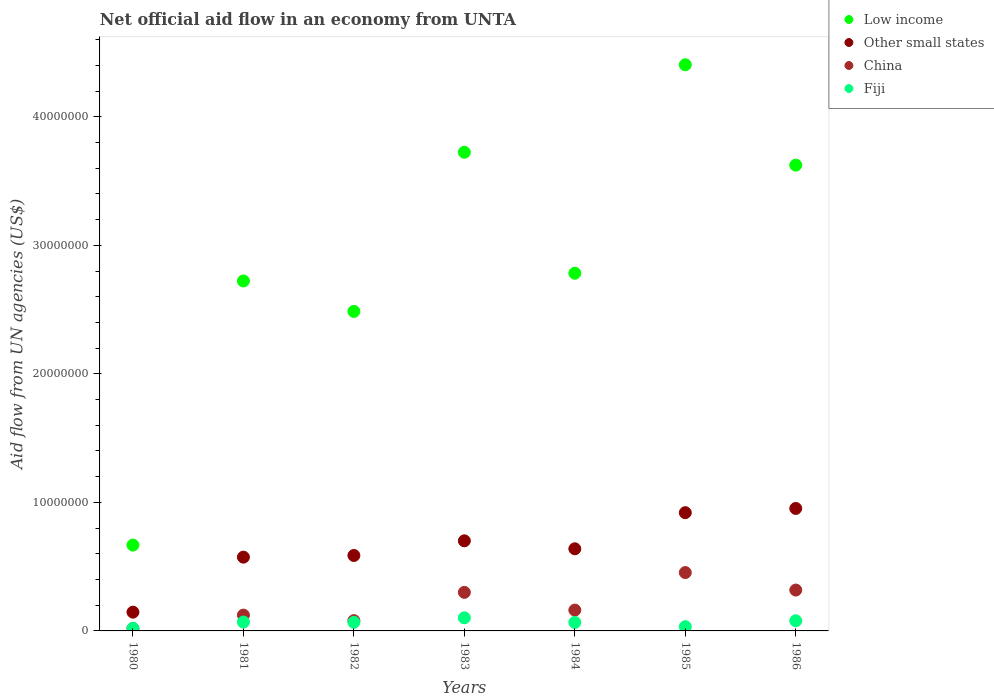How many different coloured dotlines are there?
Provide a short and direct response. 4. What is the net official aid flow in China in 1986?
Offer a very short reply. 3.18e+06. Across all years, what is the maximum net official aid flow in China?
Offer a terse response. 4.54e+06. Across all years, what is the minimum net official aid flow in Other small states?
Provide a succinct answer. 1.46e+06. What is the total net official aid flow in Low income in the graph?
Your response must be concise. 2.04e+08. What is the difference between the net official aid flow in Low income in 1983 and the net official aid flow in Fiji in 1986?
Provide a succinct answer. 3.64e+07. What is the average net official aid flow in China per year?
Make the answer very short. 2.08e+06. In the year 1982, what is the difference between the net official aid flow in Other small states and net official aid flow in Fiji?
Make the answer very short. 5.20e+06. What is the ratio of the net official aid flow in Low income in 1984 to that in 1986?
Your response must be concise. 0.77. Is the net official aid flow in Low income in 1983 less than that in 1985?
Your answer should be compact. Yes. Is the difference between the net official aid flow in Other small states in 1982 and 1984 greater than the difference between the net official aid flow in Fiji in 1982 and 1984?
Give a very brief answer. No. What is the difference between the highest and the second highest net official aid flow in Low income?
Your answer should be compact. 6.81e+06. What is the difference between the highest and the lowest net official aid flow in Low income?
Provide a succinct answer. 3.74e+07. In how many years, is the net official aid flow in Fiji greater than the average net official aid flow in Fiji taken over all years?
Give a very brief answer. 5. Is it the case that in every year, the sum of the net official aid flow in Low income and net official aid flow in Fiji  is greater than the sum of net official aid flow in China and net official aid flow in Other small states?
Your answer should be compact. Yes. Does the net official aid flow in China monotonically increase over the years?
Ensure brevity in your answer.  No. Is the net official aid flow in Other small states strictly less than the net official aid flow in Fiji over the years?
Offer a terse response. No. How many years are there in the graph?
Offer a terse response. 7. What is the difference between two consecutive major ticks on the Y-axis?
Make the answer very short. 1.00e+07. Does the graph contain any zero values?
Your answer should be very brief. No. Does the graph contain grids?
Your answer should be compact. No. How many legend labels are there?
Offer a very short reply. 4. What is the title of the graph?
Keep it short and to the point. Net official aid flow in an economy from UNTA. Does "Aruba" appear as one of the legend labels in the graph?
Offer a terse response. No. What is the label or title of the Y-axis?
Offer a very short reply. Aid flow from UN agencies (US$). What is the Aid flow from UN agencies (US$) in Low income in 1980?
Ensure brevity in your answer.  6.68e+06. What is the Aid flow from UN agencies (US$) of Other small states in 1980?
Offer a terse response. 1.46e+06. What is the Aid flow from UN agencies (US$) in China in 1980?
Provide a succinct answer. 1.90e+05. What is the Aid flow from UN agencies (US$) of Low income in 1981?
Make the answer very short. 2.72e+07. What is the Aid flow from UN agencies (US$) in Other small states in 1981?
Provide a short and direct response. 5.74e+06. What is the Aid flow from UN agencies (US$) in China in 1981?
Provide a short and direct response. 1.23e+06. What is the Aid flow from UN agencies (US$) in Fiji in 1981?
Your answer should be compact. 6.90e+05. What is the Aid flow from UN agencies (US$) of Low income in 1982?
Offer a very short reply. 2.49e+07. What is the Aid flow from UN agencies (US$) of Other small states in 1982?
Your answer should be very brief. 5.87e+06. What is the Aid flow from UN agencies (US$) of Fiji in 1982?
Make the answer very short. 6.70e+05. What is the Aid flow from UN agencies (US$) of Low income in 1983?
Make the answer very short. 3.72e+07. What is the Aid flow from UN agencies (US$) in Other small states in 1983?
Offer a terse response. 7.01e+06. What is the Aid flow from UN agencies (US$) of Fiji in 1983?
Provide a short and direct response. 1.02e+06. What is the Aid flow from UN agencies (US$) in Low income in 1984?
Your answer should be very brief. 2.78e+07. What is the Aid flow from UN agencies (US$) of Other small states in 1984?
Keep it short and to the point. 6.39e+06. What is the Aid flow from UN agencies (US$) of China in 1984?
Your answer should be very brief. 1.62e+06. What is the Aid flow from UN agencies (US$) in Fiji in 1984?
Keep it short and to the point. 6.60e+05. What is the Aid flow from UN agencies (US$) in Low income in 1985?
Give a very brief answer. 4.40e+07. What is the Aid flow from UN agencies (US$) in Other small states in 1985?
Your answer should be compact. 9.20e+06. What is the Aid flow from UN agencies (US$) in China in 1985?
Your answer should be compact. 4.54e+06. What is the Aid flow from UN agencies (US$) in Low income in 1986?
Offer a very short reply. 3.62e+07. What is the Aid flow from UN agencies (US$) of Other small states in 1986?
Offer a terse response. 9.53e+06. What is the Aid flow from UN agencies (US$) in China in 1986?
Ensure brevity in your answer.  3.18e+06. What is the Aid flow from UN agencies (US$) in Fiji in 1986?
Your answer should be compact. 7.90e+05. Across all years, what is the maximum Aid flow from UN agencies (US$) in Low income?
Make the answer very short. 4.40e+07. Across all years, what is the maximum Aid flow from UN agencies (US$) in Other small states?
Your answer should be compact. 9.53e+06. Across all years, what is the maximum Aid flow from UN agencies (US$) of China?
Make the answer very short. 4.54e+06. Across all years, what is the maximum Aid flow from UN agencies (US$) of Fiji?
Make the answer very short. 1.02e+06. Across all years, what is the minimum Aid flow from UN agencies (US$) of Low income?
Ensure brevity in your answer.  6.68e+06. Across all years, what is the minimum Aid flow from UN agencies (US$) of Other small states?
Give a very brief answer. 1.46e+06. What is the total Aid flow from UN agencies (US$) of Low income in the graph?
Make the answer very short. 2.04e+08. What is the total Aid flow from UN agencies (US$) in Other small states in the graph?
Make the answer very short. 4.52e+07. What is the total Aid flow from UN agencies (US$) of China in the graph?
Provide a succinct answer. 1.46e+07. What is the total Aid flow from UN agencies (US$) of Fiji in the graph?
Offer a terse response. 4.36e+06. What is the difference between the Aid flow from UN agencies (US$) in Low income in 1980 and that in 1981?
Offer a very short reply. -2.06e+07. What is the difference between the Aid flow from UN agencies (US$) in Other small states in 1980 and that in 1981?
Give a very brief answer. -4.28e+06. What is the difference between the Aid flow from UN agencies (US$) of China in 1980 and that in 1981?
Provide a succinct answer. -1.04e+06. What is the difference between the Aid flow from UN agencies (US$) in Fiji in 1980 and that in 1981?
Provide a short and direct response. -4.90e+05. What is the difference between the Aid flow from UN agencies (US$) of Low income in 1980 and that in 1982?
Provide a short and direct response. -1.82e+07. What is the difference between the Aid flow from UN agencies (US$) in Other small states in 1980 and that in 1982?
Provide a succinct answer. -4.41e+06. What is the difference between the Aid flow from UN agencies (US$) in China in 1980 and that in 1982?
Give a very brief answer. -6.10e+05. What is the difference between the Aid flow from UN agencies (US$) in Fiji in 1980 and that in 1982?
Your answer should be very brief. -4.70e+05. What is the difference between the Aid flow from UN agencies (US$) in Low income in 1980 and that in 1983?
Your response must be concise. -3.06e+07. What is the difference between the Aid flow from UN agencies (US$) of Other small states in 1980 and that in 1983?
Your answer should be compact. -5.55e+06. What is the difference between the Aid flow from UN agencies (US$) of China in 1980 and that in 1983?
Give a very brief answer. -2.81e+06. What is the difference between the Aid flow from UN agencies (US$) of Fiji in 1980 and that in 1983?
Your answer should be very brief. -8.20e+05. What is the difference between the Aid flow from UN agencies (US$) of Low income in 1980 and that in 1984?
Give a very brief answer. -2.12e+07. What is the difference between the Aid flow from UN agencies (US$) in Other small states in 1980 and that in 1984?
Provide a succinct answer. -4.93e+06. What is the difference between the Aid flow from UN agencies (US$) of China in 1980 and that in 1984?
Offer a very short reply. -1.43e+06. What is the difference between the Aid flow from UN agencies (US$) of Fiji in 1980 and that in 1984?
Offer a terse response. -4.60e+05. What is the difference between the Aid flow from UN agencies (US$) in Low income in 1980 and that in 1985?
Provide a succinct answer. -3.74e+07. What is the difference between the Aid flow from UN agencies (US$) in Other small states in 1980 and that in 1985?
Your answer should be very brief. -7.74e+06. What is the difference between the Aid flow from UN agencies (US$) in China in 1980 and that in 1985?
Provide a short and direct response. -4.35e+06. What is the difference between the Aid flow from UN agencies (US$) in Low income in 1980 and that in 1986?
Offer a very short reply. -2.96e+07. What is the difference between the Aid flow from UN agencies (US$) of Other small states in 1980 and that in 1986?
Your answer should be very brief. -8.07e+06. What is the difference between the Aid flow from UN agencies (US$) of China in 1980 and that in 1986?
Ensure brevity in your answer.  -2.99e+06. What is the difference between the Aid flow from UN agencies (US$) in Fiji in 1980 and that in 1986?
Make the answer very short. -5.90e+05. What is the difference between the Aid flow from UN agencies (US$) in Low income in 1981 and that in 1982?
Your response must be concise. 2.37e+06. What is the difference between the Aid flow from UN agencies (US$) in China in 1981 and that in 1982?
Ensure brevity in your answer.  4.30e+05. What is the difference between the Aid flow from UN agencies (US$) of Fiji in 1981 and that in 1982?
Your answer should be very brief. 2.00e+04. What is the difference between the Aid flow from UN agencies (US$) in Low income in 1981 and that in 1983?
Offer a very short reply. -1.00e+07. What is the difference between the Aid flow from UN agencies (US$) of Other small states in 1981 and that in 1983?
Keep it short and to the point. -1.27e+06. What is the difference between the Aid flow from UN agencies (US$) of China in 1981 and that in 1983?
Offer a very short reply. -1.77e+06. What is the difference between the Aid flow from UN agencies (US$) in Fiji in 1981 and that in 1983?
Make the answer very short. -3.30e+05. What is the difference between the Aid flow from UN agencies (US$) in Low income in 1981 and that in 1984?
Offer a terse response. -6.00e+05. What is the difference between the Aid flow from UN agencies (US$) in Other small states in 1981 and that in 1984?
Provide a short and direct response. -6.50e+05. What is the difference between the Aid flow from UN agencies (US$) in China in 1981 and that in 1984?
Give a very brief answer. -3.90e+05. What is the difference between the Aid flow from UN agencies (US$) of Low income in 1981 and that in 1985?
Provide a succinct answer. -1.68e+07. What is the difference between the Aid flow from UN agencies (US$) of Other small states in 1981 and that in 1985?
Your response must be concise. -3.46e+06. What is the difference between the Aid flow from UN agencies (US$) of China in 1981 and that in 1985?
Offer a very short reply. -3.31e+06. What is the difference between the Aid flow from UN agencies (US$) of Fiji in 1981 and that in 1985?
Your answer should be compact. 3.60e+05. What is the difference between the Aid flow from UN agencies (US$) in Low income in 1981 and that in 1986?
Provide a short and direct response. -9.01e+06. What is the difference between the Aid flow from UN agencies (US$) in Other small states in 1981 and that in 1986?
Keep it short and to the point. -3.79e+06. What is the difference between the Aid flow from UN agencies (US$) in China in 1981 and that in 1986?
Make the answer very short. -1.95e+06. What is the difference between the Aid flow from UN agencies (US$) in Fiji in 1981 and that in 1986?
Your response must be concise. -1.00e+05. What is the difference between the Aid flow from UN agencies (US$) of Low income in 1982 and that in 1983?
Give a very brief answer. -1.24e+07. What is the difference between the Aid flow from UN agencies (US$) of Other small states in 1982 and that in 1983?
Provide a short and direct response. -1.14e+06. What is the difference between the Aid flow from UN agencies (US$) in China in 1982 and that in 1983?
Your answer should be compact. -2.20e+06. What is the difference between the Aid flow from UN agencies (US$) in Fiji in 1982 and that in 1983?
Ensure brevity in your answer.  -3.50e+05. What is the difference between the Aid flow from UN agencies (US$) in Low income in 1982 and that in 1984?
Keep it short and to the point. -2.97e+06. What is the difference between the Aid flow from UN agencies (US$) in Other small states in 1982 and that in 1984?
Provide a succinct answer. -5.20e+05. What is the difference between the Aid flow from UN agencies (US$) in China in 1982 and that in 1984?
Provide a short and direct response. -8.20e+05. What is the difference between the Aid flow from UN agencies (US$) in Fiji in 1982 and that in 1984?
Your response must be concise. 10000. What is the difference between the Aid flow from UN agencies (US$) in Low income in 1982 and that in 1985?
Provide a short and direct response. -1.92e+07. What is the difference between the Aid flow from UN agencies (US$) of Other small states in 1982 and that in 1985?
Your answer should be very brief. -3.33e+06. What is the difference between the Aid flow from UN agencies (US$) in China in 1982 and that in 1985?
Keep it short and to the point. -3.74e+06. What is the difference between the Aid flow from UN agencies (US$) in Low income in 1982 and that in 1986?
Provide a succinct answer. -1.14e+07. What is the difference between the Aid flow from UN agencies (US$) in Other small states in 1982 and that in 1986?
Provide a short and direct response. -3.66e+06. What is the difference between the Aid flow from UN agencies (US$) of China in 1982 and that in 1986?
Offer a terse response. -2.38e+06. What is the difference between the Aid flow from UN agencies (US$) of Fiji in 1982 and that in 1986?
Your response must be concise. -1.20e+05. What is the difference between the Aid flow from UN agencies (US$) of Low income in 1983 and that in 1984?
Offer a terse response. 9.41e+06. What is the difference between the Aid flow from UN agencies (US$) in Other small states in 1983 and that in 1984?
Offer a very short reply. 6.20e+05. What is the difference between the Aid flow from UN agencies (US$) of China in 1983 and that in 1984?
Your answer should be very brief. 1.38e+06. What is the difference between the Aid flow from UN agencies (US$) in Low income in 1983 and that in 1985?
Provide a short and direct response. -6.81e+06. What is the difference between the Aid flow from UN agencies (US$) of Other small states in 1983 and that in 1985?
Make the answer very short. -2.19e+06. What is the difference between the Aid flow from UN agencies (US$) of China in 1983 and that in 1985?
Make the answer very short. -1.54e+06. What is the difference between the Aid flow from UN agencies (US$) in Fiji in 1983 and that in 1985?
Give a very brief answer. 6.90e+05. What is the difference between the Aid flow from UN agencies (US$) in Low income in 1983 and that in 1986?
Offer a terse response. 1.00e+06. What is the difference between the Aid flow from UN agencies (US$) of Other small states in 1983 and that in 1986?
Offer a terse response. -2.52e+06. What is the difference between the Aid flow from UN agencies (US$) in Low income in 1984 and that in 1985?
Keep it short and to the point. -1.62e+07. What is the difference between the Aid flow from UN agencies (US$) in Other small states in 1984 and that in 1985?
Your response must be concise. -2.81e+06. What is the difference between the Aid flow from UN agencies (US$) in China in 1984 and that in 1985?
Provide a succinct answer. -2.92e+06. What is the difference between the Aid flow from UN agencies (US$) in Low income in 1984 and that in 1986?
Offer a terse response. -8.41e+06. What is the difference between the Aid flow from UN agencies (US$) in Other small states in 1984 and that in 1986?
Offer a terse response. -3.14e+06. What is the difference between the Aid flow from UN agencies (US$) of China in 1984 and that in 1986?
Your answer should be compact. -1.56e+06. What is the difference between the Aid flow from UN agencies (US$) in Low income in 1985 and that in 1986?
Keep it short and to the point. 7.81e+06. What is the difference between the Aid flow from UN agencies (US$) of Other small states in 1985 and that in 1986?
Give a very brief answer. -3.30e+05. What is the difference between the Aid flow from UN agencies (US$) in China in 1985 and that in 1986?
Offer a terse response. 1.36e+06. What is the difference between the Aid flow from UN agencies (US$) in Fiji in 1985 and that in 1986?
Keep it short and to the point. -4.60e+05. What is the difference between the Aid flow from UN agencies (US$) in Low income in 1980 and the Aid flow from UN agencies (US$) in Other small states in 1981?
Keep it short and to the point. 9.40e+05. What is the difference between the Aid flow from UN agencies (US$) in Low income in 1980 and the Aid flow from UN agencies (US$) in China in 1981?
Offer a terse response. 5.45e+06. What is the difference between the Aid flow from UN agencies (US$) in Low income in 1980 and the Aid flow from UN agencies (US$) in Fiji in 1981?
Ensure brevity in your answer.  5.99e+06. What is the difference between the Aid flow from UN agencies (US$) in Other small states in 1980 and the Aid flow from UN agencies (US$) in Fiji in 1981?
Your response must be concise. 7.70e+05. What is the difference between the Aid flow from UN agencies (US$) of China in 1980 and the Aid flow from UN agencies (US$) of Fiji in 1981?
Offer a terse response. -5.00e+05. What is the difference between the Aid flow from UN agencies (US$) in Low income in 1980 and the Aid flow from UN agencies (US$) in Other small states in 1982?
Ensure brevity in your answer.  8.10e+05. What is the difference between the Aid flow from UN agencies (US$) of Low income in 1980 and the Aid flow from UN agencies (US$) of China in 1982?
Provide a succinct answer. 5.88e+06. What is the difference between the Aid flow from UN agencies (US$) in Low income in 1980 and the Aid flow from UN agencies (US$) in Fiji in 1982?
Give a very brief answer. 6.01e+06. What is the difference between the Aid flow from UN agencies (US$) in Other small states in 1980 and the Aid flow from UN agencies (US$) in Fiji in 1982?
Provide a succinct answer. 7.90e+05. What is the difference between the Aid flow from UN agencies (US$) of China in 1980 and the Aid flow from UN agencies (US$) of Fiji in 1982?
Ensure brevity in your answer.  -4.80e+05. What is the difference between the Aid flow from UN agencies (US$) in Low income in 1980 and the Aid flow from UN agencies (US$) in Other small states in 1983?
Offer a very short reply. -3.30e+05. What is the difference between the Aid flow from UN agencies (US$) in Low income in 1980 and the Aid flow from UN agencies (US$) in China in 1983?
Keep it short and to the point. 3.68e+06. What is the difference between the Aid flow from UN agencies (US$) in Low income in 1980 and the Aid flow from UN agencies (US$) in Fiji in 1983?
Keep it short and to the point. 5.66e+06. What is the difference between the Aid flow from UN agencies (US$) of Other small states in 1980 and the Aid flow from UN agencies (US$) of China in 1983?
Ensure brevity in your answer.  -1.54e+06. What is the difference between the Aid flow from UN agencies (US$) of Other small states in 1980 and the Aid flow from UN agencies (US$) of Fiji in 1983?
Offer a terse response. 4.40e+05. What is the difference between the Aid flow from UN agencies (US$) of China in 1980 and the Aid flow from UN agencies (US$) of Fiji in 1983?
Make the answer very short. -8.30e+05. What is the difference between the Aid flow from UN agencies (US$) in Low income in 1980 and the Aid flow from UN agencies (US$) in China in 1984?
Make the answer very short. 5.06e+06. What is the difference between the Aid flow from UN agencies (US$) in Low income in 1980 and the Aid flow from UN agencies (US$) in Fiji in 1984?
Give a very brief answer. 6.02e+06. What is the difference between the Aid flow from UN agencies (US$) in Other small states in 1980 and the Aid flow from UN agencies (US$) in China in 1984?
Keep it short and to the point. -1.60e+05. What is the difference between the Aid flow from UN agencies (US$) in Other small states in 1980 and the Aid flow from UN agencies (US$) in Fiji in 1984?
Keep it short and to the point. 8.00e+05. What is the difference between the Aid flow from UN agencies (US$) in China in 1980 and the Aid flow from UN agencies (US$) in Fiji in 1984?
Provide a succinct answer. -4.70e+05. What is the difference between the Aid flow from UN agencies (US$) in Low income in 1980 and the Aid flow from UN agencies (US$) in Other small states in 1985?
Your response must be concise. -2.52e+06. What is the difference between the Aid flow from UN agencies (US$) in Low income in 1980 and the Aid flow from UN agencies (US$) in China in 1985?
Keep it short and to the point. 2.14e+06. What is the difference between the Aid flow from UN agencies (US$) in Low income in 1980 and the Aid flow from UN agencies (US$) in Fiji in 1985?
Your answer should be very brief. 6.35e+06. What is the difference between the Aid flow from UN agencies (US$) in Other small states in 1980 and the Aid flow from UN agencies (US$) in China in 1985?
Give a very brief answer. -3.08e+06. What is the difference between the Aid flow from UN agencies (US$) in Other small states in 1980 and the Aid flow from UN agencies (US$) in Fiji in 1985?
Make the answer very short. 1.13e+06. What is the difference between the Aid flow from UN agencies (US$) in China in 1980 and the Aid flow from UN agencies (US$) in Fiji in 1985?
Make the answer very short. -1.40e+05. What is the difference between the Aid flow from UN agencies (US$) of Low income in 1980 and the Aid flow from UN agencies (US$) of Other small states in 1986?
Keep it short and to the point. -2.85e+06. What is the difference between the Aid flow from UN agencies (US$) in Low income in 1980 and the Aid flow from UN agencies (US$) in China in 1986?
Your answer should be very brief. 3.50e+06. What is the difference between the Aid flow from UN agencies (US$) in Low income in 1980 and the Aid flow from UN agencies (US$) in Fiji in 1986?
Ensure brevity in your answer.  5.89e+06. What is the difference between the Aid flow from UN agencies (US$) in Other small states in 1980 and the Aid flow from UN agencies (US$) in China in 1986?
Your answer should be compact. -1.72e+06. What is the difference between the Aid flow from UN agencies (US$) of Other small states in 1980 and the Aid flow from UN agencies (US$) of Fiji in 1986?
Your answer should be compact. 6.70e+05. What is the difference between the Aid flow from UN agencies (US$) of China in 1980 and the Aid flow from UN agencies (US$) of Fiji in 1986?
Your answer should be very brief. -6.00e+05. What is the difference between the Aid flow from UN agencies (US$) of Low income in 1981 and the Aid flow from UN agencies (US$) of Other small states in 1982?
Provide a succinct answer. 2.14e+07. What is the difference between the Aid flow from UN agencies (US$) in Low income in 1981 and the Aid flow from UN agencies (US$) in China in 1982?
Provide a short and direct response. 2.64e+07. What is the difference between the Aid flow from UN agencies (US$) of Low income in 1981 and the Aid flow from UN agencies (US$) of Fiji in 1982?
Give a very brief answer. 2.66e+07. What is the difference between the Aid flow from UN agencies (US$) of Other small states in 1981 and the Aid flow from UN agencies (US$) of China in 1982?
Provide a short and direct response. 4.94e+06. What is the difference between the Aid flow from UN agencies (US$) in Other small states in 1981 and the Aid flow from UN agencies (US$) in Fiji in 1982?
Offer a terse response. 5.07e+06. What is the difference between the Aid flow from UN agencies (US$) in China in 1981 and the Aid flow from UN agencies (US$) in Fiji in 1982?
Make the answer very short. 5.60e+05. What is the difference between the Aid flow from UN agencies (US$) of Low income in 1981 and the Aid flow from UN agencies (US$) of Other small states in 1983?
Offer a terse response. 2.02e+07. What is the difference between the Aid flow from UN agencies (US$) of Low income in 1981 and the Aid flow from UN agencies (US$) of China in 1983?
Give a very brief answer. 2.42e+07. What is the difference between the Aid flow from UN agencies (US$) in Low income in 1981 and the Aid flow from UN agencies (US$) in Fiji in 1983?
Your answer should be very brief. 2.62e+07. What is the difference between the Aid flow from UN agencies (US$) of Other small states in 1981 and the Aid flow from UN agencies (US$) of China in 1983?
Offer a very short reply. 2.74e+06. What is the difference between the Aid flow from UN agencies (US$) in Other small states in 1981 and the Aid flow from UN agencies (US$) in Fiji in 1983?
Provide a short and direct response. 4.72e+06. What is the difference between the Aid flow from UN agencies (US$) of China in 1981 and the Aid flow from UN agencies (US$) of Fiji in 1983?
Make the answer very short. 2.10e+05. What is the difference between the Aid flow from UN agencies (US$) in Low income in 1981 and the Aid flow from UN agencies (US$) in Other small states in 1984?
Make the answer very short. 2.08e+07. What is the difference between the Aid flow from UN agencies (US$) of Low income in 1981 and the Aid flow from UN agencies (US$) of China in 1984?
Give a very brief answer. 2.56e+07. What is the difference between the Aid flow from UN agencies (US$) of Low income in 1981 and the Aid flow from UN agencies (US$) of Fiji in 1984?
Make the answer very short. 2.66e+07. What is the difference between the Aid flow from UN agencies (US$) of Other small states in 1981 and the Aid flow from UN agencies (US$) of China in 1984?
Ensure brevity in your answer.  4.12e+06. What is the difference between the Aid flow from UN agencies (US$) of Other small states in 1981 and the Aid flow from UN agencies (US$) of Fiji in 1984?
Provide a succinct answer. 5.08e+06. What is the difference between the Aid flow from UN agencies (US$) of China in 1981 and the Aid flow from UN agencies (US$) of Fiji in 1984?
Offer a terse response. 5.70e+05. What is the difference between the Aid flow from UN agencies (US$) in Low income in 1981 and the Aid flow from UN agencies (US$) in Other small states in 1985?
Offer a terse response. 1.80e+07. What is the difference between the Aid flow from UN agencies (US$) in Low income in 1981 and the Aid flow from UN agencies (US$) in China in 1985?
Provide a succinct answer. 2.27e+07. What is the difference between the Aid flow from UN agencies (US$) in Low income in 1981 and the Aid flow from UN agencies (US$) in Fiji in 1985?
Offer a very short reply. 2.69e+07. What is the difference between the Aid flow from UN agencies (US$) of Other small states in 1981 and the Aid flow from UN agencies (US$) of China in 1985?
Provide a succinct answer. 1.20e+06. What is the difference between the Aid flow from UN agencies (US$) in Other small states in 1981 and the Aid flow from UN agencies (US$) in Fiji in 1985?
Your answer should be compact. 5.41e+06. What is the difference between the Aid flow from UN agencies (US$) in Low income in 1981 and the Aid flow from UN agencies (US$) in Other small states in 1986?
Your answer should be very brief. 1.77e+07. What is the difference between the Aid flow from UN agencies (US$) in Low income in 1981 and the Aid flow from UN agencies (US$) in China in 1986?
Give a very brief answer. 2.40e+07. What is the difference between the Aid flow from UN agencies (US$) in Low income in 1981 and the Aid flow from UN agencies (US$) in Fiji in 1986?
Give a very brief answer. 2.64e+07. What is the difference between the Aid flow from UN agencies (US$) of Other small states in 1981 and the Aid flow from UN agencies (US$) of China in 1986?
Offer a terse response. 2.56e+06. What is the difference between the Aid flow from UN agencies (US$) of Other small states in 1981 and the Aid flow from UN agencies (US$) of Fiji in 1986?
Give a very brief answer. 4.95e+06. What is the difference between the Aid flow from UN agencies (US$) in Low income in 1982 and the Aid flow from UN agencies (US$) in Other small states in 1983?
Your answer should be very brief. 1.78e+07. What is the difference between the Aid flow from UN agencies (US$) of Low income in 1982 and the Aid flow from UN agencies (US$) of China in 1983?
Give a very brief answer. 2.19e+07. What is the difference between the Aid flow from UN agencies (US$) of Low income in 1982 and the Aid flow from UN agencies (US$) of Fiji in 1983?
Make the answer very short. 2.38e+07. What is the difference between the Aid flow from UN agencies (US$) in Other small states in 1982 and the Aid flow from UN agencies (US$) in China in 1983?
Your answer should be very brief. 2.87e+06. What is the difference between the Aid flow from UN agencies (US$) of Other small states in 1982 and the Aid flow from UN agencies (US$) of Fiji in 1983?
Your response must be concise. 4.85e+06. What is the difference between the Aid flow from UN agencies (US$) of China in 1982 and the Aid flow from UN agencies (US$) of Fiji in 1983?
Offer a very short reply. -2.20e+05. What is the difference between the Aid flow from UN agencies (US$) in Low income in 1982 and the Aid flow from UN agencies (US$) in Other small states in 1984?
Provide a succinct answer. 1.85e+07. What is the difference between the Aid flow from UN agencies (US$) in Low income in 1982 and the Aid flow from UN agencies (US$) in China in 1984?
Ensure brevity in your answer.  2.32e+07. What is the difference between the Aid flow from UN agencies (US$) in Low income in 1982 and the Aid flow from UN agencies (US$) in Fiji in 1984?
Provide a short and direct response. 2.42e+07. What is the difference between the Aid flow from UN agencies (US$) in Other small states in 1982 and the Aid flow from UN agencies (US$) in China in 1984?
Your answer should be very brief. 4.25e+06. What is the difference between the Aid flow from UN agencies (US$) in Other small states in 1982 and the Aid flow from UN agencies (US$) in Fiji in 1984?
Your answer should be compact. 5.21e+06. What is the difference between the Aid flow from UN agencies (US$) of China in 1982 and the Aid flow from UN agencies (US$) of Fiji in 1984?
Keep it short and to the point. 1.40e+05. What is the difference between the Aid flow from UN agencies (US$) in Low income in 1982 and the Aid flow from UN agencies (US$) in Other small states in 1985?
Provide a short and direct response. 1.57e+07. What is the difference between the Aid flow from UN agencies (US$) of Low income in 1982 and the Aid flow from UN agencies (US$) of China in 1985?
Your response must be concise. 2.03e+07. What is the difference between the Aid flow from UN agencies (US$) of Low income in 1982 and the Aid flow from UN agencies (US$) of Fiji in 1985?
Make the answer very short. 2.45e+07. What is the difference between the Aid flow from UN agencies (US$) in Other small states in 1982 and the Aid flow from UN agencies (US$) in China in 1985?
Make the answer very short. 1.33e+06. What is the difference between the Aid flow from UN agencies (US$) in Other small states in 1982 and the Aid flow from UN agencies (US$) in Fiji in 1985?
Provide a short and direct response. 5.54e+06. What is the difference between the Aid flow from UN agencies (US$) of China in 1982 and the Aid flow from UN agencies (US$) of Fiji in 1985?
Provide a succinct answer. 4.70e+05. What is the difference between the Aid flow from UN agencies (US$) of Low income in 1982 and the Aid flow from UN agencies (US$) of Other small states in 1986?
Your response must be concise. 1.53e+07. What is the difference between the Aid flow from UN agencies (US$) of Low income in 1982 and the Aid flow from UN agencies (US$) of China in 1986?
Offer a terse response. 2.17e+07. What is the difference between the Aid flow from UN agencies (US$) in Low income in 1982 and the Aid flow from UN agencies (US$) in Fiji in 1986?
Provide a succinct answer. 2.41e+07. What is the difference between the Aid flow from UN agencies (US$) in Other small states in 1982 and the Aid flow from UN agencies (US$) in China in 1986?
Ensure brevity in your answer.  2.69e+06. What is the difference between the Aid flow from UN agencies (US$) of Other small states in 1982 and the Aid flow from UN agencies (US$) of Fiji in 1986?
Provide a short and direct response. 5.08e+06. What is the difference between the Aid flow from UN agencies (US$) in Low income in 1983 and the Aid flow from UN agencies (US$) in Other small states in 1984?
Offer a very short reply. 3.08e+07. What is the difference between the Aid flow from UN agencies (US$) in Low income in 1983 and the Aid flow from UN agencies (US$) in China in 1984?
Offer a very short reply. 3.56e+07. What is the difference between the Aid flow from UN agencies (US$) of Low income in 1983 and the Aid flow from UN agencies (US$) of Fiji in 1984?
Ensure brevity in your answer.  3.66e+07. What is the difference between the Aid flow from UN agencies (US$) in Other small states in 1983 and the Aid flow from UN agencies (US$) in China in 1984?
Provide a succinct answer. 5.39e+06. What is the difference between the Aid flow from UN agencies (US$) in Other small states in 1983 and the Aid flow from UN agencies (US$) in Fiji in 1984?
Your response must be concise. 6.35e+06. What is the difference between the Aid flow from UN agencies (US$) of China in 1983 and the Aid flow from UN agencies (US$) of Fiji in 1984?
Offer a terse response. 2.34e+06. What is the difference between the Aid flow from UN agencies (US$) of Low income in 1983 and the Aid flow from UN agencies (US$) of Other small states in 1985?
Your answer should be compact. 2.80e+07. What is the difference between the Aid flow from UN agencies (US$) of Low income in 1983 and the Aid flow from UN agencies (US$) of China in 1985?
Your answer should be very brief. 3.27e+07. What is the difference between the Aid flow from UN agencies (US$) in Low income in 1983 and the Aid flow from UN agencies (US$) in Fiji in 1985?
Keep it short and to the point. 3.69e+07. What is the difference between the Aid flow from UN agencies (US$) in Other small states in 1983 and the Aid flow from UN agencies (US$) in China in 1985?
Your response must be concise. 2.47e+06. What is the difference between the Aid flow from UN agencies (US$) in Other small states in 1983 and the Aid flow from UN agencies (US$) in Fiji in 1985?
Keep it short and to the point. 6.68e+06. What is the difference between the Aid flow from UN agencies (US$) in China in 1983 and the Aid flow from UN agencies (US$) in Fiji in 1985?
Offer a very short reply. 2.67e+06. What is the difference between the Aid flow from UN agencies (US$) in Low income in 1983 and the Aid flow from UN agencies (US$) in Other small states in 1986?
Give a very brief answer. 2.77e+07. What is the difference between the Aid flow from UN agencies (US$) of Low income in 1983 and the Aid flow from UN agencies (US$) of China in 1986?
Ensure brevity in your answer.  3.41e+07. What is the difference between the Aid flow from UN agencies (US$) in Low income in 1983 and the Aid flow from UN agencies (US$) in Fiji in 1986?
Provide a short and direct response. 3.64e+07. What is the difference between the Aid flow from UN agencies (US$) of Other small states in 1983 and the Aid flow from UN agencies (US$) of China in 1986?
Make the answer very short. 3.83e+06. What is the difference between the Aid flow from UN agencies (US$) of Other small states in 1983 and the Aid flow from UN agencies (US$) of Fiji in 1986?
Your answer should be very brief. 6.22e+06. What is the difference between the Aid flow from UN agencies (US$) of China in 1983 and the Aid flow from UN agencies (US$) of Fiji in 1986?
Provide a succinct answer. 2.21e+06. What is the difference between the Aid flow from UN agencies (US$) in Low income in 1984 and the Aid flow from UN agencies (US$) in Other small states in 1985?
Offer a terse response. 1.86e+07. What is the difference between the Aid flow from UN agencies (US$) in Low income in 1984 and the Aid flow from UN agencies (US$) in China in 1985?
Provide a short and direct response. 2.33e+07. What is the difference between the Aid flow from UN agencies (US$) in Low income in 1984 and the Aid flow from UN agencies (US$) in Fiji in 1985?
Provide a succinct answer. 2.75e+07. What is the difference between the Aid flow from UN agencies (US$) of Other small states in 1984 and the Aid flow from UN agencies (US$) of China in 1985?
Your answer should be very brief. 1.85e+06. What is the difference between the Aid flow from UN agencies (US$) in Other small states in 1984 and the Aid flow from UN agencies (US$) in Fiji in 1985?
Give a very brief answer. 6.06e+06. What is the difference between the Aid flow from UN agencies (US$) in China in 1984 and the Aid flow from UN agencies (US$) in Fiji in 1985?
Your response must be concise. 1.29e+06. What is the difference between the Aid flow from UN agencies (US$) of Low income in 1984 and the Aid flow from UN agencies (US$) of Other small states in 1986?
Give a very brief answer. 1.83e+07. What is the difference between the Aid flow from UN agencies (US$) of Low income in 1984 and the Aid flow from UN agencies (US$) of China in 1986?
Your response must be concise. 2.46e+07. What is the difference between the Aid flow from UN agencies (US$) of Low income in 1984 and the Aid flow from UN agencies (US$) of Fiji in 1986?
Make the answer very short. 2.70e+07. What is the difference between the Aid flow from UN agencies (US$) in Other small states in 1984 and the Aid flow from UN agencies (US$) in China in 1986?
Your answer should be very brief. 3.21e+06. What is the difference between the Aid flow from UN agencies (US$) of Other small states in 1984 and the Aid flow from UN agencies (US$) of Fiji in 1986?
Your response must be concise. 5.60e+06. What is the difference between the Aid flow from UN agencies (US$) of China in 1984 and the Aid flow from UN agencies (US$) of Fiji in 1986?
Offer a terse response. 8.30e+05. What is the difference between the Aid flow from UN agencies (US$) in Low income in 1985 and the Aid flow from UN agencies (US$) in Other small states in 1986?
Ensure brevity in your answer.  3.45e+07. What is the difference between the Aid flow from UN agencies (US$) of Low income in 1985 and the Aid flow from UN agencies (US$) of China in 1986?
Make the answer very short. 4.09e+07. What is the difference between the Aid flow from UN agencies (US$) in Low income in 1985 and the Aid flow from UN agencies (US$) in Fiji in 1986?
Your response must be concise. 4.33e+07. What is the difference between the Aid flow from UN agencies (US$) in Other small states in 1985 and the Aid flow from UN agencies (US$) in China in 1986?
Make the answer very short. 6.02e+06. What is the difference between the Aid flow from UN agencies (US$) of Other small states in 1985 and the Aid flow from UN agencies (US$) of Fiji in 1986?
Your answer should be compact. 8.41e+06. What is the difference between the Aid flow from UN agencies (US$) of China in 1985 and the Aid flow from UN agencies (US$) of Fiji in 1986?
Give a very brief answer. 3.75e+06. What is the average Aid flow from UN agencies (US$) of Low income per year?
Offer a very short reply. 2.92e+07. What is the average Aid flow from UN agencies (US$) of Other small states per year?
Provide a succinct answer. 6.46e+06. What is the average Aid flow from UN agencies (US$) of China per year?
Offer a very short reply. 2.08e+06. What is the average Aid flow from UN agencies (US$) in Fiji per year?
Offer a very short reply. 6.23e+05. In the year 1980, what is the difference between the Aid flow from UN agencies (US$) in Low income and Aid flow from UN agencies (US$) in Other small states?
Offer a terse response. 5.22e+06. In the year 1980, what is the difference between the Aid flow from UN agencies (US$) in Low income and Aid flow from UN agencies (US$) in China?
Your answer should be compact. 6.49e+06. In the year 1980, what is the difference between the Aid flow from UN agencies (US$) of Low income and Aid flow from UN agencies (US$) of Fiji?
Your answer should be very brief. 6.48e+06. In the year 1980, what is the difference between the Aid flow from UN agencies (US$) of Other small states and Aid flow from UN agencies (US$) of China?
Your answer should be compact. 1.27e+06. In the year 1980, what is the difference between the Aid flow from UN agencies (US$) of Other small states and Aid flow from UN agencies (US$) of Fiji?
Keep it short and to the point. 1.26e+06. In the year 1980, what is the difference between the Aid flow from UN agencies (US$) of China and Aid flow from UN agencies (US$) of Fiji?
Make the answer very short. -10000. In the year 1981, what is the difference between the Aid flow from UN agencies (US$) of Low income and Aid flow from UN agencies (US$) of Other small states?
Provide a succinct answer. 2.15e+07. In the year 1981, what is the difference between the Aid flow from UN agencies (US$) in Low income and Aid flow from UN agencies (US$) in China?
Keep it short and to the point. 2.60e+07. In the year 1981, what is the difference between the Aid flow from UN agencies (US$) of Low income and Aid flow from UN agencies (US$) of Fiji?
Provide a short and direct response. 2.65e+07. In the year 1981, what is the difference between the Aid flow from UN agencies (US$) of Other small states and Aid flow from UN agencies (US$) of China?
Your answer should be compact. 4.51e+06. In the year 1981, what is the difference between the Aid flow from UN agencies (US$) of Other small states and Aid flow from UN agencies (US$) of Fiji?
Offer a terse response. 5.05e+06. In the year 1981, what is the difference between the Aid flow from UN agencies (US$) of China and Aid flow from UN agencies (US$) of Fiji?
Your response must be concise. 5.40e+05. In the year 1982, what is the difference between the Aid flow from UN agencies (US$) of Low income and Aid flow from UN agencies (US$) of Other small states?
Your answer should be very brief. 1.90e+07. In the year 1982, what is the difference between the Aid flow from UN agencies (US$) of Low income and Aid flow from UN agencies (US$) of China?
Give a very brief answer. 2.41e+07. In the year 1982, what is the difference between the Aid flow from UN agencies (US$) of Low income and Aid flow from UN agencies (US$) of Fiji?
Your response must be concise. 2.42e+07. In the year 1982, what is the difference between the Aid flow from UN agencies (US$) in Other small states and Aid flow from UN agencies (US$) in China?
Your answer should be compact. 5.07e+06. In the year 1982, what is the difference between the Aid flow from UN agencies (US$) in Other small states and Aid flow from UN agencies (US$) in Fiji?
Your answer should be very brief. 5.20e+06. In the year 1982, what is the difference between the Aid flow from UN agencies (US$) of China and Aid flow from UN agencies (US$) of Fiji?
Offer a terse response. 1.30e+05. In the year 1983, what is the difference between the Aid flow from UN agencies (US$) of Low income and Aid flow from UN agencies (US$) of Other small states?
Provide a succinct answer. 3.02e+07. In the year 1983, what is the difference between the Aid flow from UN agencies (US$) in Low income and Aid flow from UN agencies (US$) in China?
Your answer should be very brief. 3.42e+07. In the year 1983, what is the difference between the Aid flow from UN agencies (US$) of Low income and Aid flow from UN agencies (US$) of Fiji?
Make the answer very short. 3.62e+07. In the year 1983, what is the difference between the Aid flow from UN agencies (US$) in Other small states and Aid flow from UN agencies (US$) in China?
Provide a succinct answer. 4.01e+06. In the year 1983, what is the difference between the Aid flow from UN agencies (US$) of Other small states and Aid flow from UN agencies (US$) of Fiji?
Keep it short and to the point. 5.99e+06. In the year 1983, what is the difference between the Aid flow from UN agencies (US$) of China and Aid flow from UN agencies (US$) of Fiji?
Your answer should be very brief. 1.98e+06. In the year 1984, what is the difference between the Aid flow from UN agencies (US$) in Low income and Aid flow from UN agencies (US$) in Other small states?
Your answer should be very brief. 2.14e+07. In the year 1984, what is the difference between the Aid flow from UN agencies (US$) of Low income and Aid flow from UN agencies (US$) of China?
Your response must be concise. 2.62e+07. In the year 1984, what is the difference between the Aid flow from UN agencies (US$) in Low income and Aid flow from UN agencies (US$) in Fiji?
Provide a succinct answer. 2.72e+07. In the year 1984, what is the difference between the Aid flow from UN agencies (US$) in Other small states and Aid flow from UN agencies (US$) in China?
Make the answer very short. 4.77e+06. In the year 1984, what is the difference between the Aid flow from UN agencies (US$) in Other small states and Aid flow from UN agencies (US$) in Fiji?
Provide a short and direct response. 5.73e+06. In the year 1984, what is the difference between the Aid flow from UN agencies (US$) of China and Aid flow from UN agencies (US$) of Fiji?
Give a very brief answer. 9.60e+05. In the year 1985, what is the difference between the Aid flow from UN agencies (US$) in Low income and Aid flow from UN agencies (US$) in Other small states?
Your answer should be compact. 3.48e+07. In the year 1985, what is the difference between the Aid flow from UN agencies (US$) of Low income and Aid flow from UN agencies (US$) of China?
Offer a very short reply. 3.95e+07. In the year 1985, what is the difference between the Aid flow from UN agencies (US$) of Low income and Aid flow from UN agencies (US$) of Fiji?
Provide a short and direct response. 4.37e+07. In the year 1985, what is the difference between the Aid flow from UN agencies (US$) in Other small states and Aid flow from UN agencies (US$) in China?
Keep it short and to the point. 4.66e+06. In the year 1985, what is the difference between the Aid flow from UN agencies (US$) of Other small states and Aid flow from UN agencies (US$) of Fiji?
Provide a short and direct response. 8.87e+06. In the year 1985, what is the difference between the Aid flow from UN agencies (US$) in China and Aid flow from UN agencies (US$) in Fiji?
Your answer should be compact. 4.21e+06. In the year 1986, what is the difference between the Aid flow from UN agencies (US$) of Low income and Aid flow from UN agencies (US$) of Other small states?
Your response must be concise. 2.67e+07. In the year 1986, what is the difference between the Aid flow from UN agencies (US$) of Low income and Aid flow from UN agencies (US$) of China?
Provide a succinct answer. 3.31e+07. In the year 1986, what is the difference between the Aid flow from UN agencies (US$) in Low income and Aid flow from UN agencies (US$) in Fiji?
Provide a short and direct response. 3.54e+07. In the year 1986, what is the difference between the Aid flow from UN agencies (US$) of Other small states and Aid flow from UN agencies (US$) of China?
Give a very brief answer. 6.35e+06. In the year 1986, what is the difference between the Aid flow from UN agencies (US$) of Other small states and Aid flow from UN agencies (US$) of Fiji?
Keep it short and to the point. 8.74e+06. In the year 1986, what is the difference between the Aid flow from UN agencies (US$) of China and Aid flow from UN agencies (US$) of Fiji?
Provide a short and direct response. 2.39e+06. What is the ratio of the Aid flow from UN agencies (US$) in Low income in 1980 to that in 1981?
Make the answer very short. 0.25. What is the ratio of the Aid flow from UN agencies (US$) of Other small states in 1980 to that in 1981?
Provide a succinct answer. 0.25. What is the ratio of the Aid flow from UN agencies (US$) of China in 1980 to that in 1981?
Your response must be concise. 0.15. What is the ratio of the Aid flow from UN agencies (US$) in Fiji in 1980 to that in 1981?
Your answer should be compact. 0.29. What is the ratio of the Aid flow from UN agencies (US$) in Low income in 1980 to that in 1982?
Give a very brief answer. 0.27. What is the ratio of the Aid flow from UN agencies (US$) in Other small states in 1980 to that in 1982?
Your answer should be very brief. 0.25. What is the ratio of the Aid flow from UN agencies (US$) of China in 1980 to that in 1982?
Your answer should be very brief. 0.24. What is the ratio of the Aid flow from UN agencies (US$) in Fiji in 1980 to that in 1982?
Offer a terse response. 0.3. What is the ratio of the Aid flow from UN agencies (US$) of Low income in 1980 to that in 1983?
Make the answer very short. 0.18. What is the ratio of the Aid flow from UN agencies (US$) of Other small states in 1980 to that in 1983?
Your answer should be compact. 0.21. What is the ratio of the Aid flow from UN agencies (US$) in China in 1980 to that in 1983?
Ensure brevity in your answer.  0.06. What is the ratio of the Aid flow from UN agencies (US$) in Fiji in 1980 to that in 1983?
Provide a short and direct response. 0.2. What is the ratio of the Aid flow from UN agencies (US$) in Low income in 1980 to that in 1984?
Your response must be concise. 0.24. What is the ratio of the Aid flow from UN agencies (US$) in Other small states in 1980 to that in 1984?
Give a very brief answer. 0.23. What is the ratio of the Aid flow from UN agencies (US$) of China in 1980 to that in 1984?
Ensure brevity in your answer.  0.12. What is the ratio of the Aid flow from UN agencies (US$) in Fiji in 1980 to that in 1984?
Make the answer very short. 0.3. What is the ratio of the Aid flow from UN agencies (US$) in Low income in 1980 to that in 1985?
Provide a short and direct response. 0.15. What is the ratio of the Aid flow from UN agencies (US$) of Other small states in 1980 to that in 1985?
Give a very brief answer. 0.16. What is the ratio of the Aid flow from UN agencies (US$) in China in 1980 to that in 1985?
Make the answer very short. 0.04. What is the ratio of the Aid flow from UN agencies (US$) in Fiji in 1980 to that in 1985?
Offer a terse response. 0.61. What is the ratio of the Aid flow from UN agencies (US$) of Low income in 1980 to that in 1986?
Your answer should be very brief. 0.18. What is the ratio of the Aid flow from UN agencies (US$) in Other small states in 1980 to that in 1986?
Provide a succinct answer. 0.15. What is the ratio of the Aid flow from UN agencies (US$) in China in 1980 to that in 1986?
Give a very brief answer. 0.06. What is the ratio of the Aid flow from UN agencies (US$) in Fiji in 1980 to that in 1986?
Make the answer very short. 0.25. What is the ratio of the Aid flow from UN agencies (US$) in Low income in 1981 to that in 1982?
Offer a terse response. 1.1. What is the ratio of the Aid flow from UN agencies (US$) in Other small states in 1981 to that in 1982?
Your answer should be compact. 0.98. What is the ratio of the Aid flow from UN agencies (US$) of China in 1981 to that in 1982?
Offer a very short reply. 1.54. What is the ratio of the Aid flow from UN agencies (US$) of Fiji in 1981 to that in 1982?
Offer a very short reply. 1.03. What is the ratio of the Aid flow from UN agencies (US$) in Low income in 1981 to that in 1983?
Provide a succinct answer. 0.73. What is the ratio of the Aid flow from UN agencies (US$) in Other small states in 1981 to that in 1983?
Make the answer very short. 0.82. What is the ratio of the Aid flow from UN agencies (US$) of China in 1981 to that in 1983?
Offer a terse response. 0.41. What is the ratio of the Aid flow from UN agencies (US$) in Fiji in 1981 to that in 1983?
Provide a succinct answer. 0.68. What is the ratio of the Aid flow from UN agencies (US$) in Low income in 1981 to that in 1984?
Your answer should be compact. 0.98. What is the ratio of the Aid flow from UN agencies (US$) of Other small states in 1981 to that in 1984?
Your answer should be very brief. 0.9. What is the ratio of the Aid flow from UN agencies (US$) in China in 1981 to that in 1984?
Your response must be concise. 0.76. What is the ratio of the Aid flow from UN agencies (US$) in Fiji in 1981 to that in 1984?
Offer a very short reply. 1.05. What is the ratio of the Aid flow from UN agencies (US$) in Low income in 1981 to that in 1985?
Give a very brief answer. 0.62. What is the ratio of the Aid flow from UN agencies (US$) of Other small states in 1981 to that in 1985?
Ensure brevity in your answer.  0.62. What is the ratio of the Aid flow from UN agencies (US$) of China in 1981 to that in 1985?
Keep it short and to the point. 0.27. What is the ratio of the Aid flow from UN agencies (US$) of Fiji in 1981 to that in 1985?
Make the answer very short. 2.09. What is the ratio of the Aid flow from UN agencies (US$) of Low income in 1981 to that in 1986?
Make the answer very short. 0.75. What is the ratio of the Aid flow from UN agencies (US$) of Other small states in 1981 to that in 1986?
Your answer should be compact. 0.6. What is the ratio of the Aid flow from UN agencies (US$) in China in 1981 to that in 1986?
Your answer should be compact. 0.39. What is the ratio of the Aid flow from UN agencies (US$) of Fiji in 1981 to that in 1986?
Offer a terse response. 0.87. What is the ratio of the Aid flow from UN agencies (US$) in Low income in 1982 to that in 1983?
Provide a short and direct response. 0.67. What is the ratio of the Aid flow from UN agencies (US$) in Other small states in 1982 to that in 1983?
Make the answer very short. 0.84. What is the ratio of the Aid flow from UN agencies (US$) of China in 1982 to that in 1983?
Offer a very short reply. 0.27. What is the ratio of the Aid flow from UN agencies (US$) in Fiji in 1982 to that in 1983?
Make the answer very short. 0.66. What is the ratio of the Aid flow from UN agencies (US$) of Low income in 1982 to that in 1984?
Your answer should be compact. 0.89. What is the ratio of the Aid flow from UN agencies (US$) in Other small states in 1982 to that in 1984?
Provide a short and direct response. 0.92. What is the ratio of the Aid flow from UN agencies (US$) in China in 1982 to that in 1984?
Keep it short and to the point. 0.49. What is the ratio of the Aid flow from UN agencies (US$) in Fiji in 1982 to that in 1984?
Provide a succinct answer. 1.02. What is the ratio of the Aid flow from UN agencies (US$) in Low income in 1982 to that in 1985?
Keep it short and to the point. 0.56. What is the ratio of the Aid flow from UN agencies (US$) of Other small states in 1982 to that in 1985?
Keep it short and to the point. 0.64. What is the ratio of the Aid flow from UN agencies (US$) in China in 1982 to that in 1985?
Provide a short and direct response. 0.18. What is the ratio of the Aid flow from UN agencies (US$) in Fiji in 1982 to that in 1985?
Give a very brief answer. 2.03. What is the ratio of the Aid flow from UN agencies (US$) in Low income in 1982 to that in 1986?
Your response must be concise. 0.69. What is the ratio of the Aid flow from UN agencies (US$) in Other small states in 1982 to that in 1986?
Your answer should be compact. 0.62. What is the ratio of the Aid flow from UN agencies (US$) of China in 1982 to that in 1986?
Give a very brief answer. 0.25. What is the ratio of the Aid flow from UN agencies (US$) of Fiji in 1982 to that in 1986?
Your answer should be very brief. 0.85. What is the ratio of the Aid flow from UN agencies (US$) in Low income in 1983 to that in 1984?
Provide a short and direct response. 1.34. What is the ratio of the Aid flow from UN agencies (US$) of Other small states in 1983 to that in 1984?
Keep it short and to the point. 1.1. What is the ratio of the Aid flow from UN agencies (US$) in China in 1983 to that in 1984?
Provide a short and direct response. 1.85. What is the ratio of the Aid flow from UN agencies (US$) of Fiji in 1983 to that in 1984?
Make the answer very short. 1.55. What is the ratio of the Aid flow from UN agencies (US$) in Low income in 1983 to that in 1985?
Ensure brevity in your answer.  0.85. What is the ratio of the Aid flow from UN agencies (US$) of Other small states in 1983 to that in 1985?
Provide a short and direct response. 0.76. What is the ratio of the Aid flow from UN agencies (US$) of China in 1983 to that in 1985?
Keep it short and to the point. 0.66. What is the ratio of the Aid flow from UN agencies (US$) in Fiji in 1983 to that in 1985?
Your answer should be very brief. 3.09. What is the ratio of the Aid flow from UN agencies (US$) of Low income in 1983 to that in 1986?
Provide a short and direct response. 1.03. What is the ratio of the Aid flow from UN agencies (US$) in Other small states in 1983 to that in 1986?
Keep it short and to the point. 0.74. What is the ratio of the Aid flow from UN agencies (US$) of China in 1983 to that in 1986?
Provide a short and direct response. 0.94. What is the ratio of the Aid flow from UN agencies (US$) of Fiji in 1983 to that in 1986?
Your answer should be compact. 1.29. What is the ratio of the Aid flow from UN agencies (US$) of Low income in 1984 to that in 1985?
Offer a very short reply. 0.63. What is the ratio of the Aid flow from UN agencies (US$) in Other small states in 1984 to that in 1985?
Offer a very short reply. 0.69. What is the ratio of the Aid flow from UN agencies (US$) of China in 1984 to that in 1985?
Keep it short and to the point. 0.36. What is the ratio of the Aid flow from UN agencies (US$) in Low income in 1984 to that in 1986?
Provide a succinct answer. 0.77. What is the ratio of the Aid flow from UN agencies (US$) in Other small states in 1984 to that in 1986?
Offer a very short reply. 0.67. What is the ratio of the Aid flow from UN agencies (US$) in China in 1984 to that in 1986?
Offer a very short reply. 0.51. What is the ratio of the Aid flow from UN agencies (US$) of Fiji in 1984 to that in 1986?
Your answer should be very brief. 0.84. What is the ratio of the Aid flow from UN agencies (US$) of Low income in 1985 to that in 1986?
Your response must be concise. 1.22. What is the ratio of the Aid flow from UN agencies (US$) of Other small states in 1985 to that in 1986?
Provide a short and direct response. 0.97. What is the ratio of the Aid flow from UN agencies (US$) in China in 1985 to that in 1986?
Your answer should be compact. 1.43. What is the ratio of the Aid flow from UN agencies (US$) of Fiji in 1985 to that in 1986?
Give a very brief answer. 0.42. What is the difference between the highest and the second highest Aid flow from UN agencies (US$) in Low income?
Your response must be concise. 6.81e+06. What is the difference between the highest and the second highest Aid flow from UN agencies (US$) of China?
Provide a succinct answer. 1.36e+06. What is the difference between the highest and the second highest Aid flow from UN agencies (US$) of Fiji?
Give a very brief answer. 2.30e+05. What is the difference between the highest and the lowest Aid flow from UN agencies (US$) of Low income?
Your answer should be very brief. 3.74e+07. What is the difference between the highest and the lowest Aid flow from UN agencies (US$) of Other small states?
Your response must be concise. 8.07e+06. What is the difference between the highest and the lowest Aid flow from UN agencies (US$) in China?
Your answer should be very brief. 4.35e+06. What is the difference between the highest and the lowest Aid flow from UN agencies (US$) of Fiji?
Your answer should be compact. 8.20e+05. 